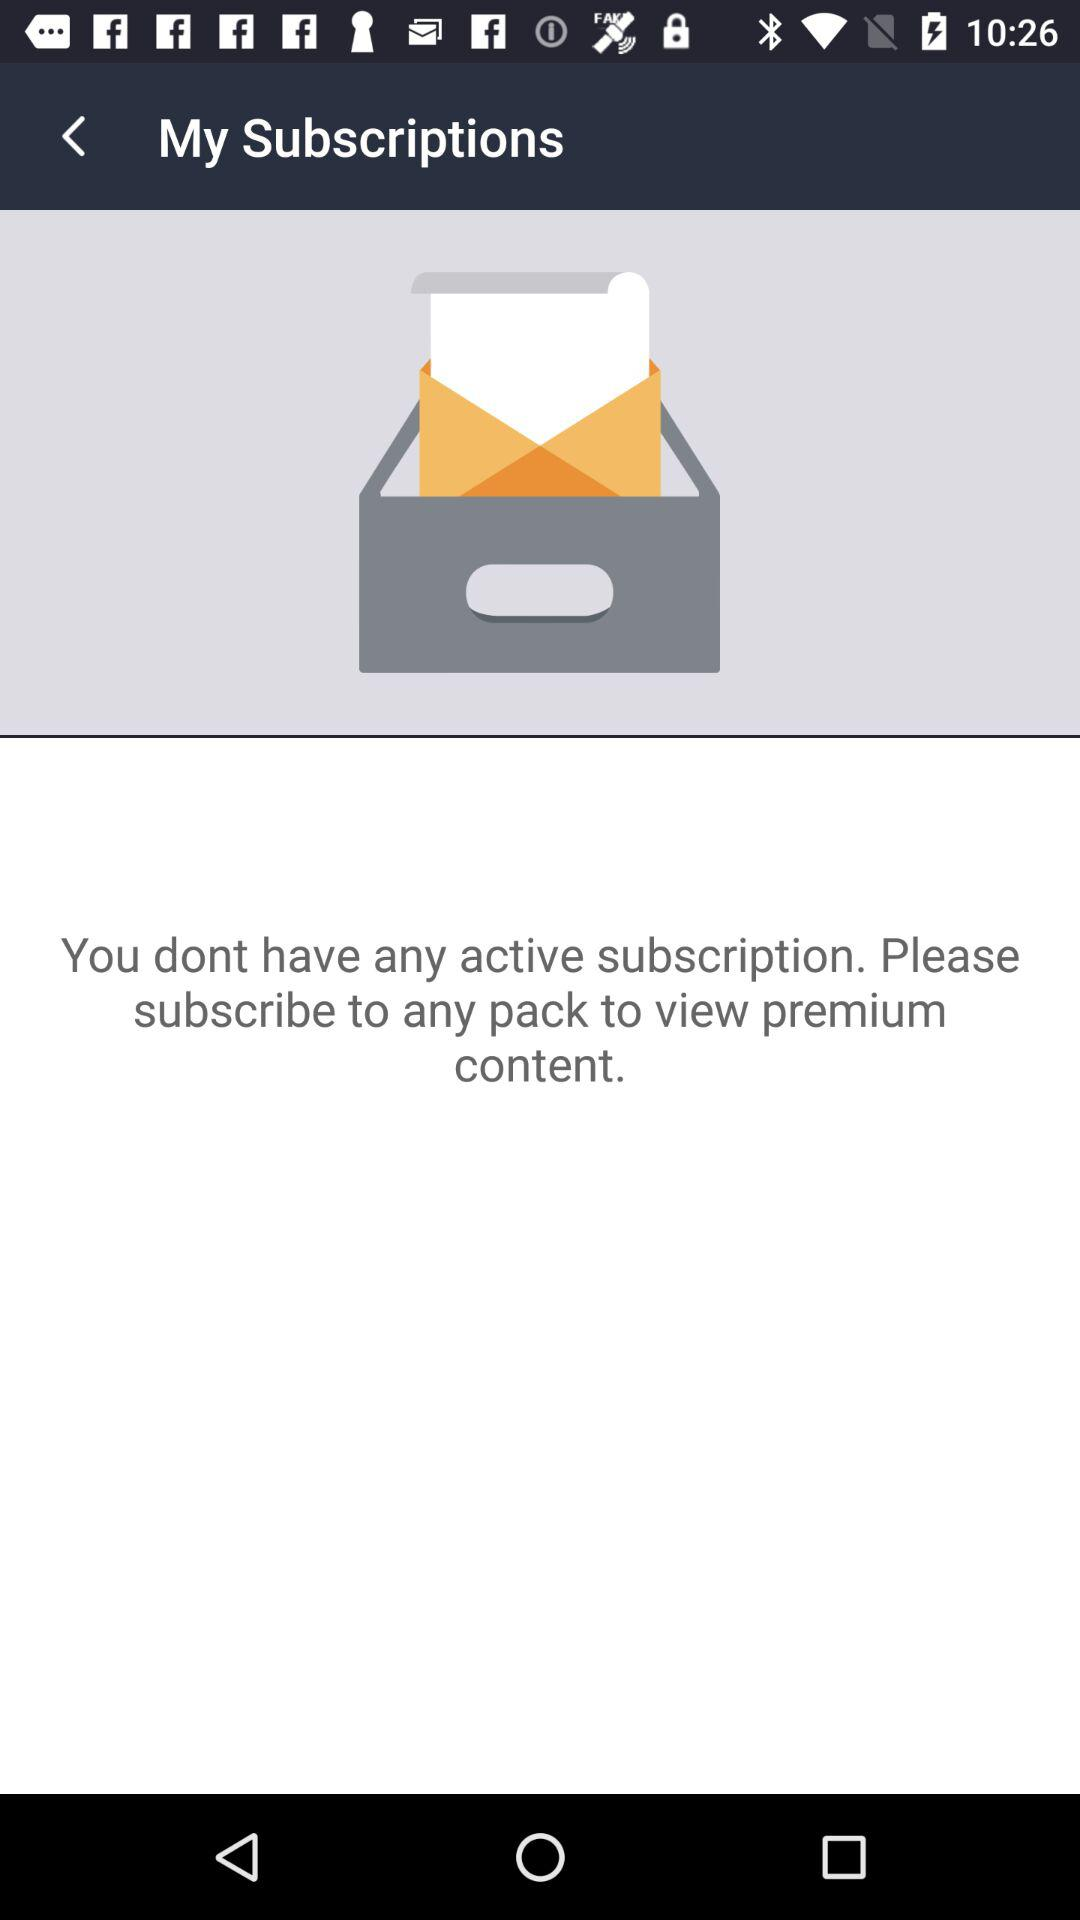How many active subscriptions do I have? 0 